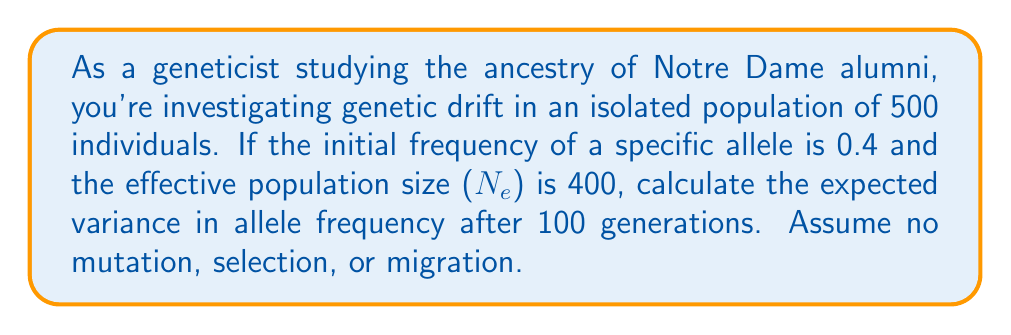Help me with this question. To solve this problem, we'll use the formula for the variance in allele frequency due to genetic drift:

$$\text{Var}(q) = \frac{q_0(1-q_0)}{2N_e}[1-e^{-t/2N_e}]$$

Where:
$q_0$ is the initial allele frequency
$N_e$ is the effective population size
$t$ is the number of generations

Step 1: Identify the given values
$q_0 = 0.4$
$N_e = 400$
$t = 100$

Step 2: Substitute the values into the formula
$$\text{Var}(q) = \frac{0.4(1-0.4)}{2(400)}[1-e^{-100/(2(400))}]$$

Step 3: Simplify the expression inside the square brackets
$$\text{Var}(q) = \frac{0.4(0.6)}{800}[1-e^{-0.125}]$$

Step 4: Calculate the value of $e^{-0.125}$
$e^{-0.125} \approx 0.882497$

Step 5: Substitute this value and simplify
$$\text{Var}(q) = \frac{0.24}{800}[1-0.882497]$$
$$\text{Var}(q) = 0.0003 \times 0.117503$$

Step 6: Calculate the final result
$$\text{Var}(q) \approx 0.00003525$$
Answer: $0.00003525$ 